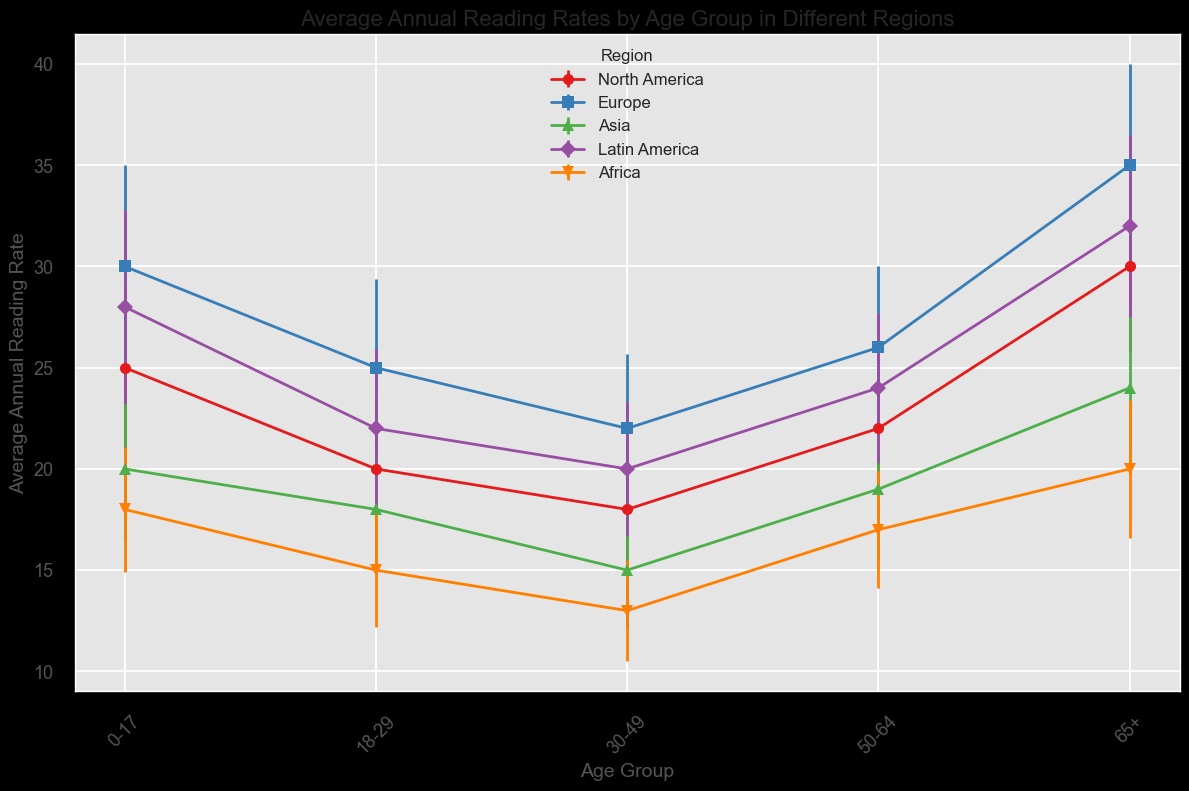Which region has the highest average annual reading rate for the 0-17 age group? The highest point on the plot for the 0-17 age group corresponds to Europe, which stands out visually compared to other regions.
Answer: Europe Which age group has the lowest average annual reading rate in Africa? By inspecting the plot for Africa, the lowest point is for the 30-49 age group.
Answer: 30-49 What's the difference between the average annual reading rates of the 65+ age group in North America and Asia? The average annual reading rate for North America (65+) is 30, while for Asia (65+) it is 24. The difference is 30 - 24 = 6.
Answer: 6 For the 18-29 age group, which region has the smallest standard deviation in the average annual reading rate? The smallest error bar visually represents the smallest standard deviation. For the 18-29 group, this corresponds to Africa.
Answer: Africa Which region shows the largest increase in average annual reading rates from the 50-64 to the 65+ age group? Comparing the increase in rates for all regions from 50-64 to 65+, Europe has the largest increase, going from 26 to 35, an increase of 9.
Answer: Europe Which age group in Latin America has an average annual reading rate closest to that of the 30-49 age group in Europe? The 30-49 age group in Europe has a rate of 22. The closest rate in Latin America is for the 50-64 group, which has a rate of 24.
Answer: 50-64 What is the range of average annual reading rates for the 18-29 age group in all regions? The highest rate for the 18-29 group is 25 (Europe), and the lowest is 15 (Africa). The range is 25 - 15 = 10.
Answer: 10 Does any region have an average annual reading rate above 30 for the 65+ age group? If so, which region(s)? Inspecting the chart, Europe (35) and Latin America (32) have rates above 30 for the 65+ age group.
Answer: Europe, Latin America What is the average value of the average annual reading rates for the 0-17 age group across all regions? Summing the rates for the 0-17 age group (25, 30, 20, 28, 18) gives a total of 121. There are 5 regions, so the average is 121 / 5 = 24.2.
Answer: 24.2 Which region and age group has the highest standard deviation in reading rates, and what is its value? The chart shows that Europe, 0-17 age group has the largest error bar visually, which is 5.
Answer: Europe, 0-17, 5 